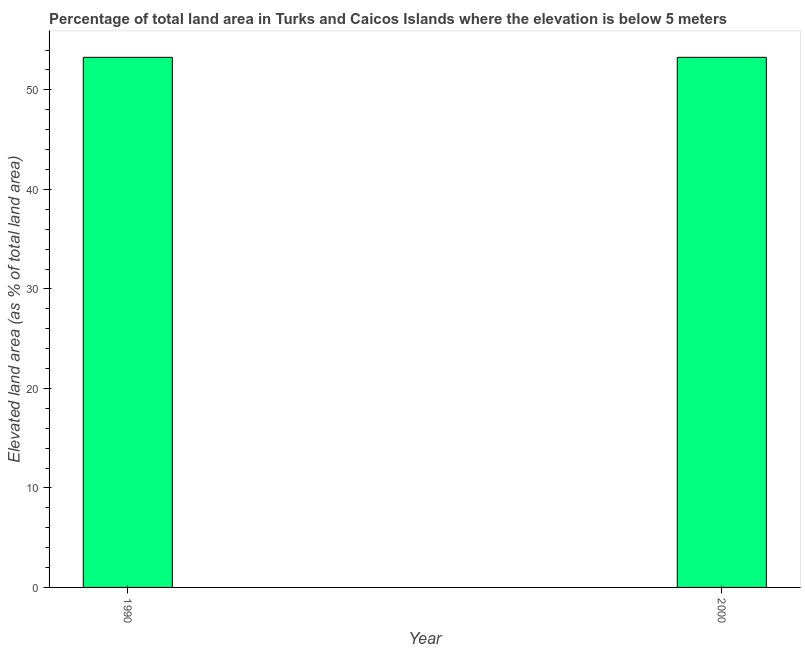Does the graph contain grids?
Provide a succinct answer. No. What is the title of the graph?
Keep it short and to the point. Percentage of total land area in Turks and Caicos Islands where the elevation is below 5 meters. What is the label or title of the Y-axis?
Offer a very short reply. Elevated land area (as % of total land area). What is the total elevated land area in 1990?
Ensure brevity in your answer.  53.27. Across all years, what is the maximum total elevated land area?
Give a very brief answer. 53.27. Across all years, what is the minimum total elevated land area?
Offer a terse response. 53.27. In which year was the total elevated land area maximum?
Offer a terse response. 1990. What is the sum of the total elevated land area?
Offer a very short reply. 106.55. What is the difference between the total elevated land area in 1990 and 2000?
Offer a terse response. 0. What is the average total elevated land area per year?
Ensure brevity in your answer.  53.27. What is the median total elevated land area?
Give a very brief answer. 53.27. Do a majority of the years between 1990 and 2000 (inclusive) have total elevated land area greater than 18 %?
Provide a short and direct response. Yes. What is the ratio of the total elevated land area in 1990 to that in 2000?
Keep it short and to the point. 1. In how many years, is the total elevated land area greater than the average total elevated land area taken over all years?
Keep it short and to the point. 0. What is the difference between two consecutive major ticks on the Y-axis?
Provide a succinct answer. 10. Are the values on the major ticks of Y-axis written in scientific E-notation?
Ensure brevity in your answer.  No. What is the Elevated land area (as % of total land area) in 1990?
Your answer should be compact. 53.27. What is the Elevated land area (as % of total land area) of 2000?
Your response must be concise. 53.27. 